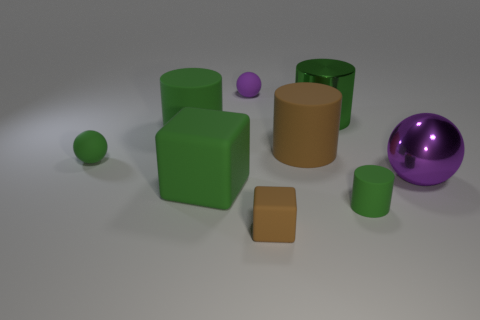Subtract all big cylinders. How many cylinders are left? 1 Subtract all brown cubes. How many purple balls are left? 2 Subtract all brown cylinders. How many cylinders are left? 3 Subtract 1 cylinders. How many cylinders are left? 3 Add 1 small brown cylinders. How many objects exist? 10 Subtract all balls. How many objects are left? 6 Subtract all blue balls. Subtract all red blocks. How many balls are left? 3 Add 1 matte things. How many matte things are left? 8 Add 6 green cylinders. How many green cylinders exist? 9 Subtract 2 purple spheres. How many objects are left? 7 